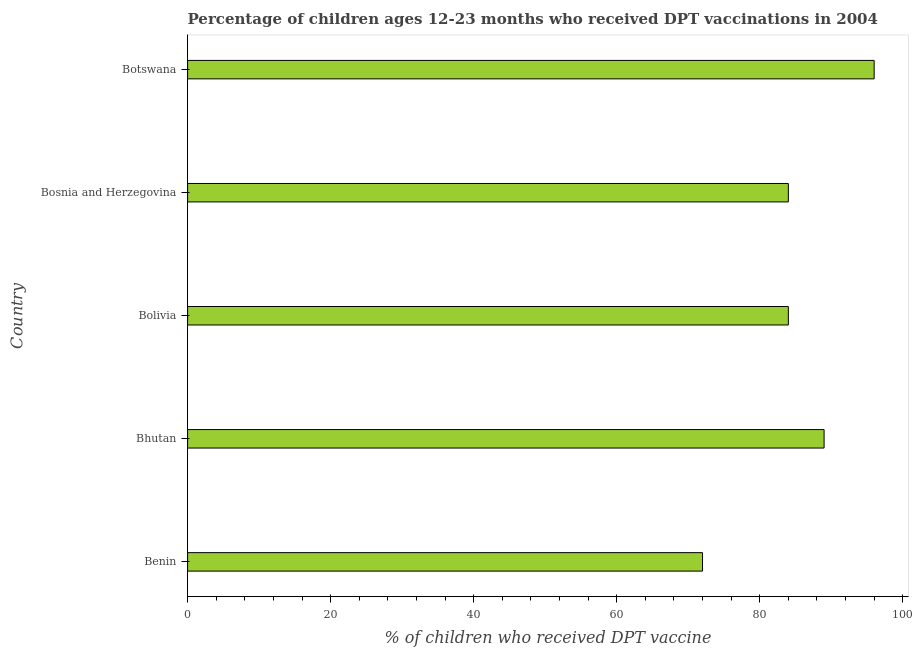What is the title of the graph?
Give a very brief answer. Percentage of children ages 12-23 months who received DPT vaccinations in 2004. What is the label or title of the X-axis?
Ensure brevity in your answer.  % of children who received DPT vaccine. What is the percentage of children who received dpt vaccine in Bhutan?
Provide a short and direct response. 89. Across all countries, what is the maximum percentage of children who received dpt vaccine?
Provide a succinct answer. 96. In which country was the percentage of children who received dpt vaccine maximum?
Ensure brevity in your answer.  Botswana. In which country was the percentage of children who received dpt vaccine minimum?
Provide a short and direct response. Benin. What is the sum of the percentage of children who received dpt vaccine?
Offer a very short reply. 425. In how many countries, is the percentage of children who received dpt vaccine greater than 92 %?
Provide a succinct answer. 1. What is the ratio of the percentage of children who received dpt vaccine in Benin to that in Bolivia?
Keep it short and to the point. 0.86. What is the difference between the highest and the second highest percentage of children who received dpt vaccine?
Provide a short and direct response. 7. Is the sum of the percentage of children who received dpt vaccine in Bolivia and Bosnia and Herzegovina greater than the maximum percentage of children who received dpt vaccine across all countries?
Ensure brevity in your answer.  Yes. What is the difference between the highest and the lowest percentage of children who received dpt vaccine?
Your answer should be very brief. 24. In how many countries, is the percentage of children who received dpt vaccine greater than the average percentage of children who received dpt vaccine taken over all countries?
Make the answer very short. 2. How many bars are there?
Make the answer very short. 5. What is the difference between two consecutive major ticks on the X-axis?
Your response must be concise. 20. Are the values on the major ticks of X-axis written in scientific E-notation?
Give a very brief answer. No. What is the % of children who received DPT vaccine in Bhutan?
Give a very brief answer. 89. What is the % of children who received DPT vaccine in Bolivia?
Your answer should be very brief. 84. What is the % of children who received DPT vaccine of Bosnia and Herzegovina?
Your response must be concise. 84. What is the % of children who received DPT vaccine of Botswana?
Give a very brief answer. 96. What is the difference between the % of children who received DPT vaccine in Benin and Bolivia?
Make the answer very short. -12. What is the difference between the % of children who received DPT vaccine in Bolivia and Bosnia and Herzegovina?
Offer a very short reply. 0. What is the difference between the % of children who received DPT vaccine in Bolivia and Botswana?
Your answer should be very brief. -12. What is the ratio of the % of children who received DPT vaccine in Benin to that in Bhutan?
Offer a terse response. 0.81. What is the ratio of the % of children who received DPT vaccine in Benin to that in Bolivia?
Offer a terse response. 0.86. What is the ratio of the % of children who received DPT vaccine in Benin to that in Bosnia and Herzegovina?
Make the answer very short. 0.86. What is the ratio of the % of children who received DPT vaccine in Bhutan to that in Bolivia?
Keep it short and to the point. 1.06. What is the ratio of the % of children who received DPT vaccine in Bhutan to that in Bosnia and Herzegovina?
Ensure brevity in your answer.  1.06. What is the ratio of the % of children who received DPT vaccine in Bhutan to that in Botswana?
Ensure brevity in your answer.  0.93. What is the ratio of the % of children who received DPT vaccine in Bolivia to that in Bosnia and Herzegovina?
Make the answer very short. 1. 